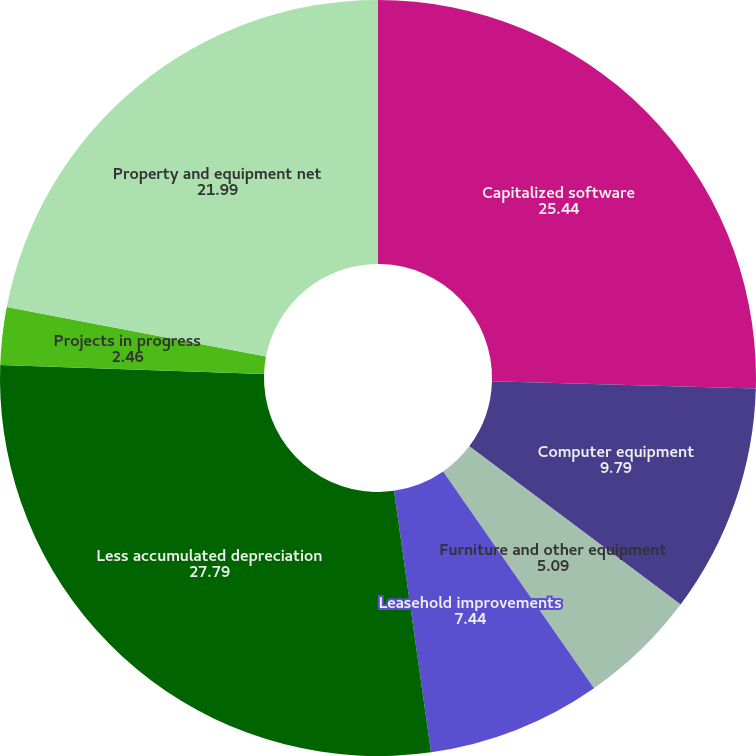Convert chart to OTSL. <chart><loc_0><loc_0><loc_500><loc_500><pie_chart><fcel>Capitalized software<fcel>Computer equipment<fcel>Furniture and other equipment<fcel>Leasehold improvements<fcel>Less accumulated depreciation<fcel>Projects in progress<fcel>Property and equipment net<nl><fcel>25.44%<fcel>9.79%<fcel>5.09%<fcel>7.44%<fcel>27.79%<fcel>2.46%<fcel>21.99%<nl></chart> 